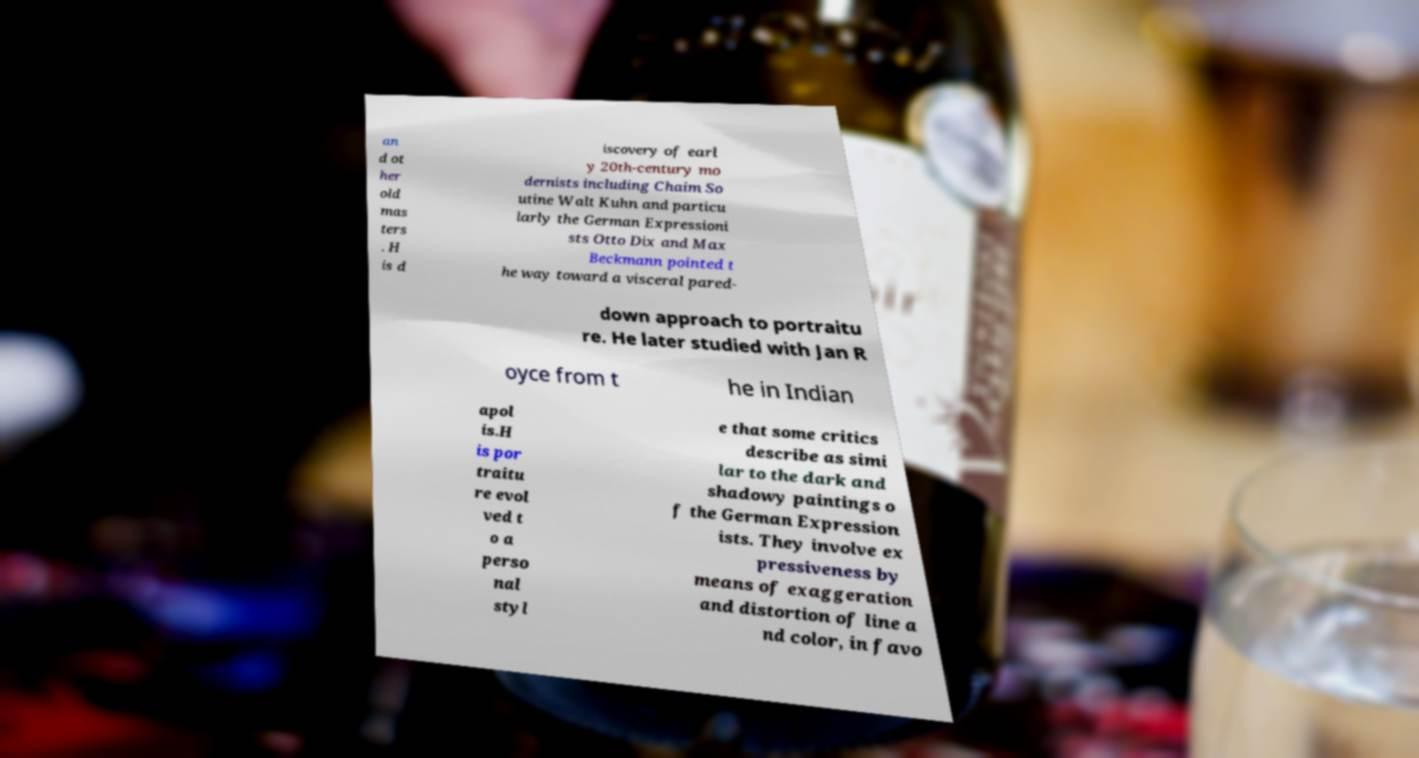Please read and relay the text visible in this image. What does it say? an d ot her old mas ters . H is d iscovery of earl y 20th-century mo dernists including Chaim So utine Walt Kuhn and particu larly the German Expressioni sts Otto Dix and Max Beckmann pointed t he way toward a visceral pared- down approach to portraitu re. He later studied with Jan R oyce from t he in Indian apol is.H is por traitu re evol ved t o a perso nal styl e that some critics describe as simi lar to the dark and shadowy paintings o f the German Expression ists. They involve ex pressiveness by means of exaggeration and distortion of line a nd color, in favo 